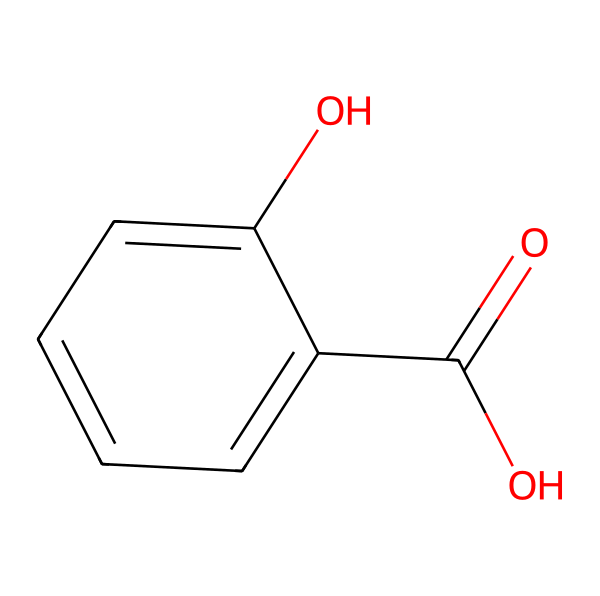What is the name of this chemical? The given SMILES representation corresponds to salicylic acid, which is explicitly identified in its structure. The structure features a hydroxyl group (–OH) and a carboxylic acid group (–COOH) attached to a benzene ring, characterizing it as salicylic acid.
Answer: salicylic acid How many carbon atoms are in this chemical? Analyzing the SMILES representation, there are six carbon atoms in the benzene ring and one each in the carboxylic acid group and the hydroxyl group, totaling eight carbon atoms. Hence, the total is eight.
Answer: 8 What functional groups are present in salicylic acid? The chemical structure shows two distinct functional groups: a hydroxyl group (–OH) and a carboxylic acid group (–COOH). Identifying these groups reveals the properties and reactivity of salicylic acid.
Answer: hydroxyl and carboxylic acid Which part of the chemical structure is responsible for its anti-acne properties? The presence of the carboxylic acid group (–COOH) is significant, as it is known for its exfoliating properties, which help in treating acne by promoting skin cell turnover and preventing clogged pores.
Answer: carboxylic acid What is the molecular weight of salicylic acid? Calculating the molecular weight involves summing the atomic weights of all atoms in the structure: 7 carbon, 6 hydrogen, and 3 oxygen atoms. The calculated total is approximately 138.12 g/mol for salicylic acid.
Answer: 138.12 g/mol 